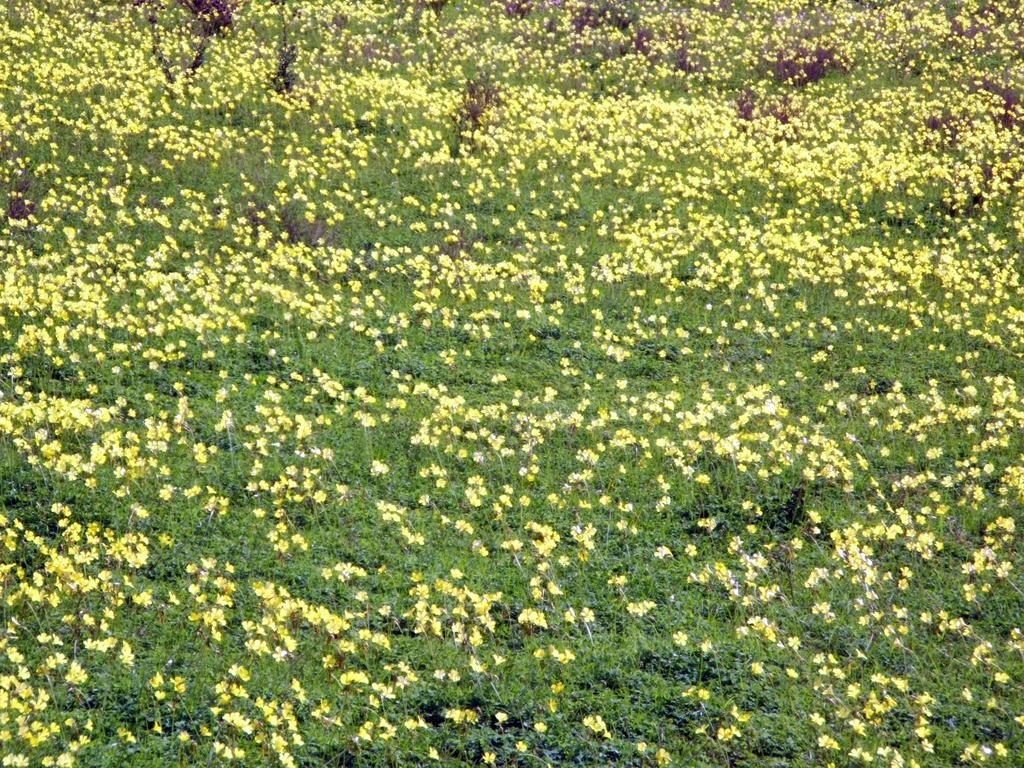What type of plants can be seen in the image? There are tiny flowers in the image. What color are the flowers? The flowers are yellow in color. Are there any other parts of the plants visible in the image? Yes, there are leaves in the image. How many goats can be seen grazing in the field in the image? There are no goats or fields present in the image; it features tiny yellow flowers and leaves. 